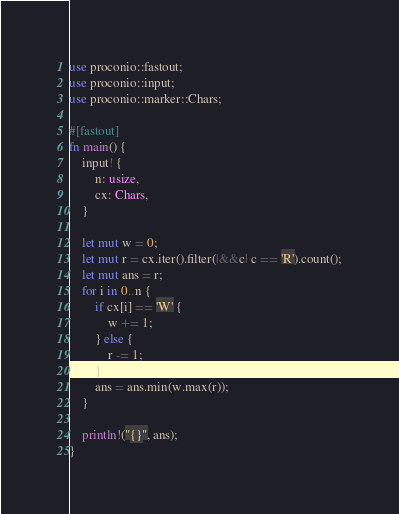Convert code to text. <code><loc_0><loc_0><loc_500><loc_500><_Rust_>use proconio::fastout;
use proconio::input;
use proconio::marker::Chars;

#[fastout]
fn main() {
    input! {
        n: usize,
        cx: Chars,
    }

    let mut w = 0;
    let mut r = cx.iter().filter(|&&c| c == 'R').count();
    let mut ans = r;
    for i in 0..n {
        if cx[i] == 'W' {
            w += 1;
        } else {
            r -= 1;
        }
        ans = ans.min(w.max(r));
    }

    println!("{}", ans);
}
</code> 